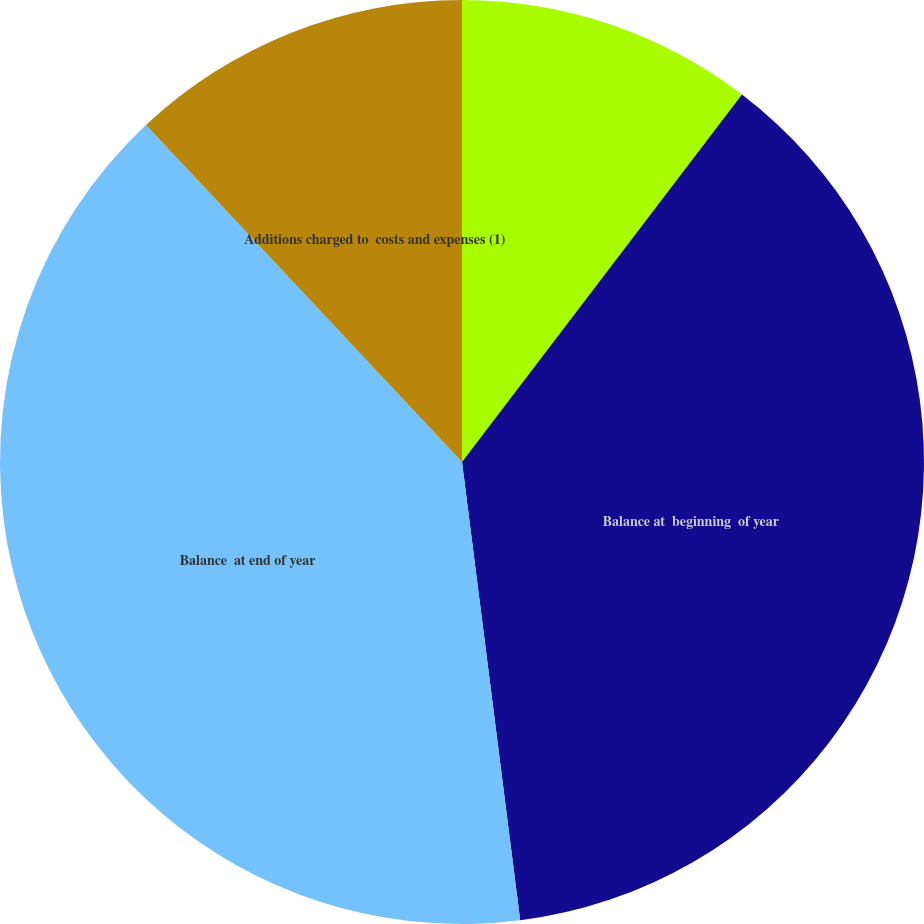<chart> <loc_0><loc_0><loc_500><loc_500><pie_chart><fcel>Deductions (2)<fcel>Balance at  beginning  of year<fcel>Balance  at end of year<fcel>Additions charged to  costs and expenses (1)<nl><fcel>10.36%<fcel>37.63%<fcel>40.02%<fcel>11.99%<nl></chart> 